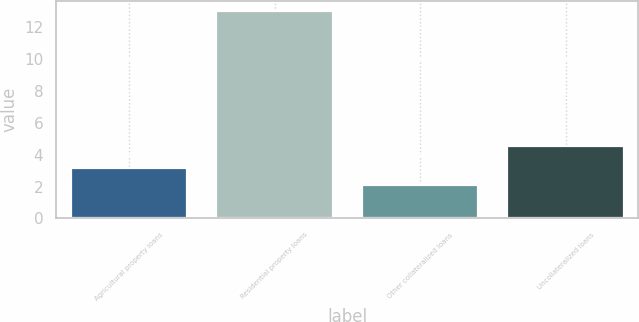Convert chart to OTSL. <chart><loc_0><loc_0><loc_500><loc_500><bar_chart><fcel>Agricultural property loans<fcel>Residential property loans<fcel>Other collateralized loans<fcel>Uncollateralized loans<nl><fcel>3.17<fcel>13<fcel>2.08<fcel>4.53<nl></chart> 